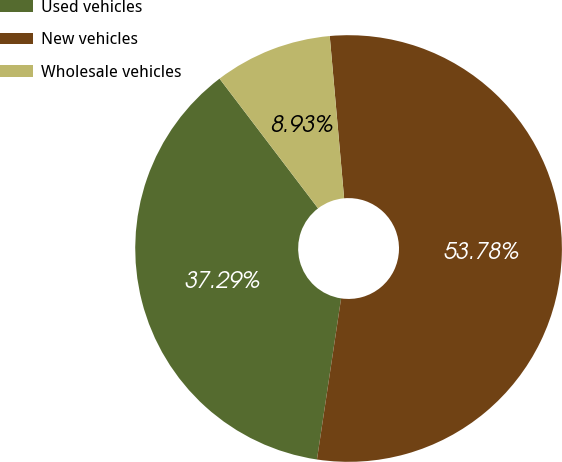Convert chart. <chart><loc_0><loc_0><loc_500><loc_500><pie_chart><fcel>Used vehicles<fcel>New vehicles<fcel>Wholesale vehicles<nl><fcel>37.29%<fcel>53.77%<fcel>8.93%<nl></chart> 